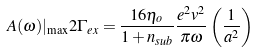Convert formula to latex. <formula><loc_0><loc_0><loc_500><loc_500>A ( \omega ) | _ { \max } 2 \Gamma _ { e x } = \frac { 1 6 \eta _ { o } } { 1 + n _ { s u b } } \frac { e ^ { 2 } v ^ { 2 } } { \pi \omega } \left ( \frac { 1 } { a ^ { 2 } } \right )</formula> 